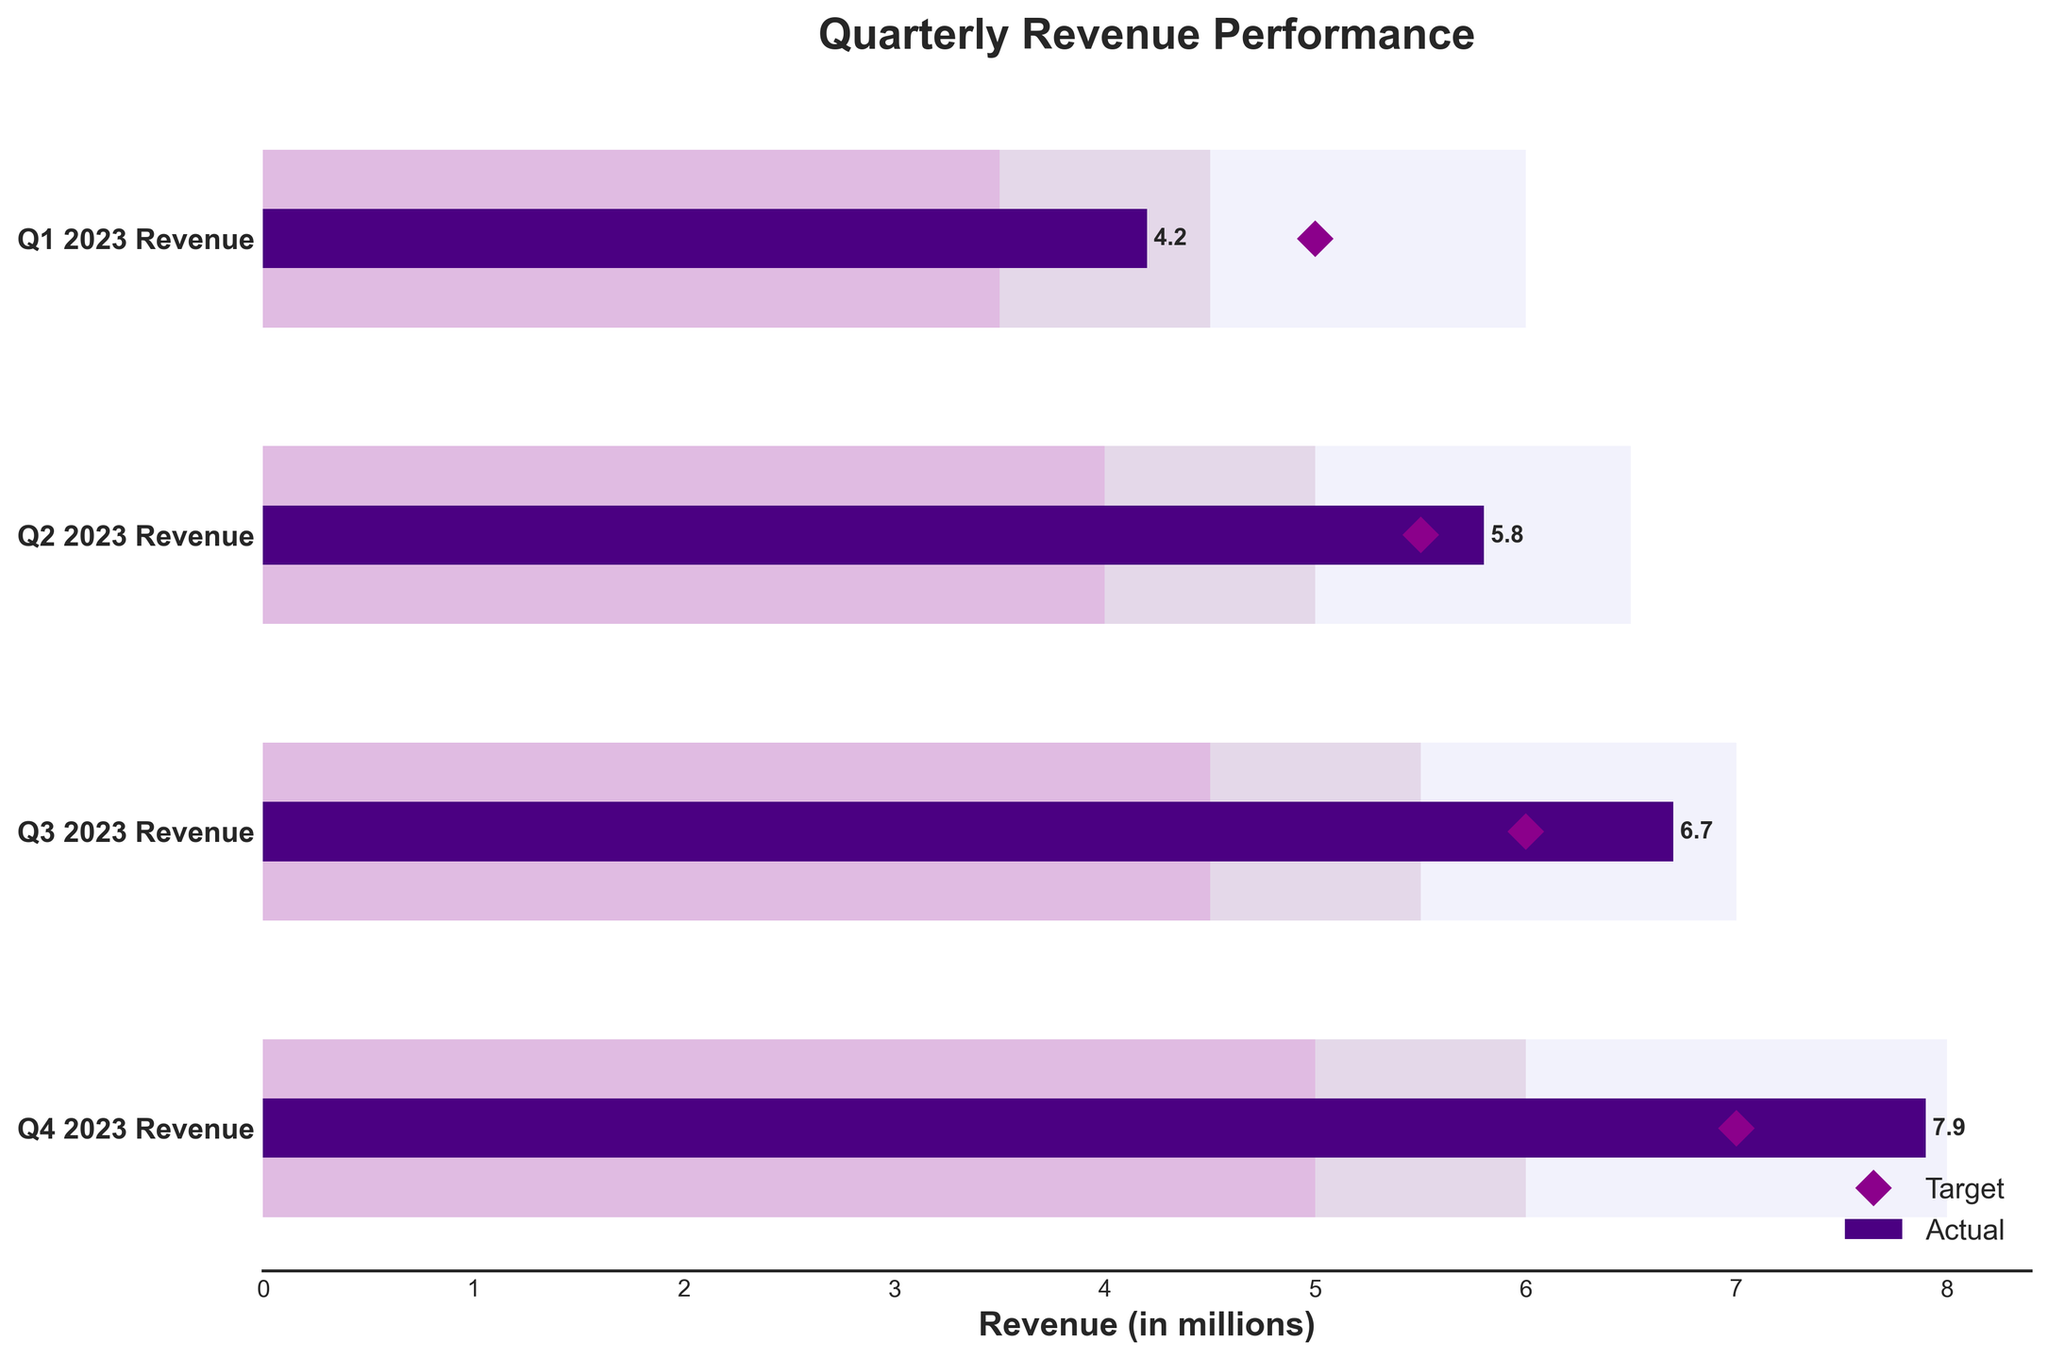What's the title of the chart? The title of the chart is given at the top and it states the overall theme of the chart.
Answer: Quarterly Revenue Performance What are the four quarters mentioned in the chart? The chart has y-axis labels, which represent the four quarters of 2023, indicating the time periods being analyzed.
Answer: Q1 2023, Q2 2023, Q3 2023, Q4 2023 What is the actual revenue for Q3 2023? The actual revenue is marked by a darker bar. For Q3 2023, the actual revenue is shown inside or at the end of the corresponding dark-colored bar.
Answer: 6.7 million In which quarter did the revenue exceed the target the most? To find this, compare the actual revenue (darker bars) for each quarter with their target (diamond shapes). The greatest difference will indicate the quarter where the revenue exceeded the target the most.
Answer: Q4 2023 Which quarter had the lowest revenue performance relative to its target? Compare the actual revenue of each quarter with its target. The quarter with the smallest proportion of its target achieved has the lowest relative performance.
Answer: Q1 2023 What are the four performance zones defined in the background of the chart? The background bars are colored differently to denote performance zones; from left to right they represent different performance levels.
Answer: Poor, Satisfactory, Good, Excellent How much higher was the actual revenue in Q2 2023 compared to its satisfactory level? Check the chart for the satisfactory level and actual revenue of Q2 2023, then subtract the satisfactory level from the actual revenue.
Answer: 1.8 million How did the actual revenue trend from Q1 2023 to Q4 2023? Observe the actual revenue (darker bars) from left to right to determine whether it is increasing, decreasing, or stable.
Answer: Increasing What is the color used to denote the 'Excellent' performance zone? The 'Excellent' performance zone is the color furthest right in the background bars.
Answer: Light purple (lavender) Which quarter achieved just satisfactory performance compared to its target? Look for the quarter where actual revenue falls within the satisfactory performance zone and compare it to its target.
Answer: None 